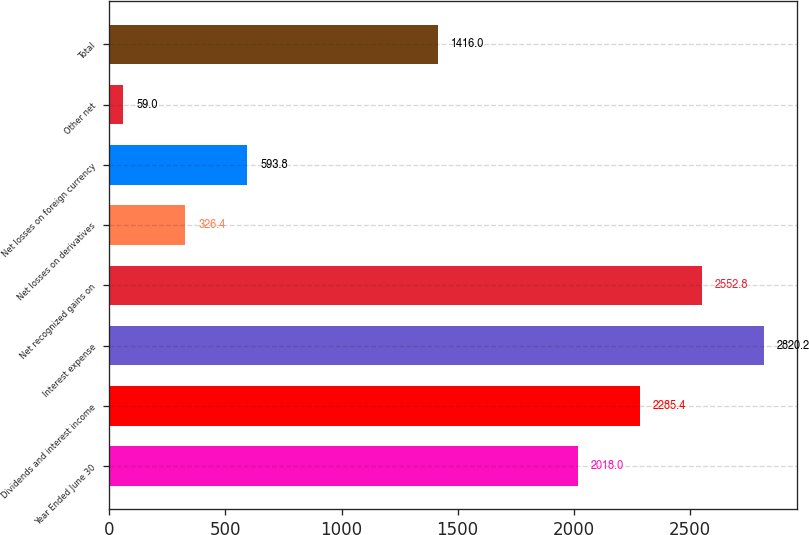Convert chart to OTSL. <chart><loc_0><loc_0><loc_500><loc_500><bar_chart><fcel>Year Ended June 30<fcel>Dividends and interest income<fcel>Interest expense<fcel>Net recognized gains on<fcel>Net losses on derivatives<fcel>Net losses on foreign currency<fcel>Other net<fcel>Total<nl><fcel>2018<fcel>2285.4<fcel>2820.2<fcel>2552.8<fcel>326.4<fcel>593.8<fcel>59<fcel>1416<nl></chart> 